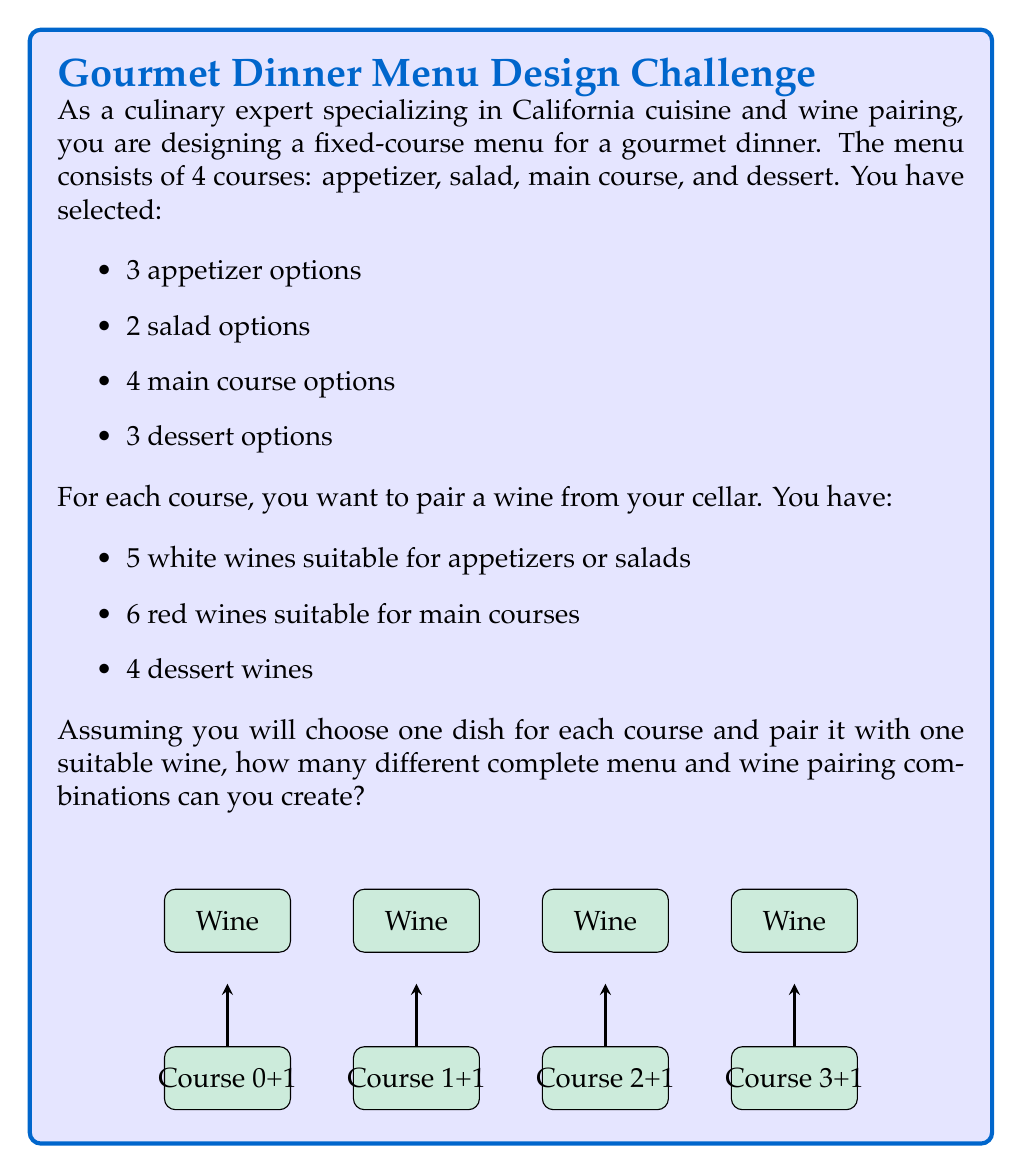Provide a solution to this math problem. Let's break this down step-by-step:

1) First, we need to calculate the number of possible dish combinations:
   - Appetizers: 3 options
   - Salads: 2 options
   - Main courses: 4 options
   - Desserts: 3 options

   Total dish combinations = $3 \times 2 \times 4 \times 3 = 72$

2) Now, for each course, we need to consider the wine pairings:
   - Appetizer: 5 white wine options
   - Salad: 5 white wine options (same as appetizer)
   - Main course: 6 red wine options
   - Dessert: 4 dessert wine options

3) For each dish combination, we have multiple wine pairing options:
   $5 \times 5 \times 6 \times 4 = 600$ wine combinations

4) By the multiplication principle, the total number of complete menu and wine pairing combinations is:

   $$ \text{Total combinations} = \text{Dish combinations} \times \text{Wine combinations per dish set} $$
   $$ = 72 \times 600 = 43,200 $$

Therefore, you can create 43,200 different complete menu and wine pairing combinations.
Answer: 43,200 combinations 